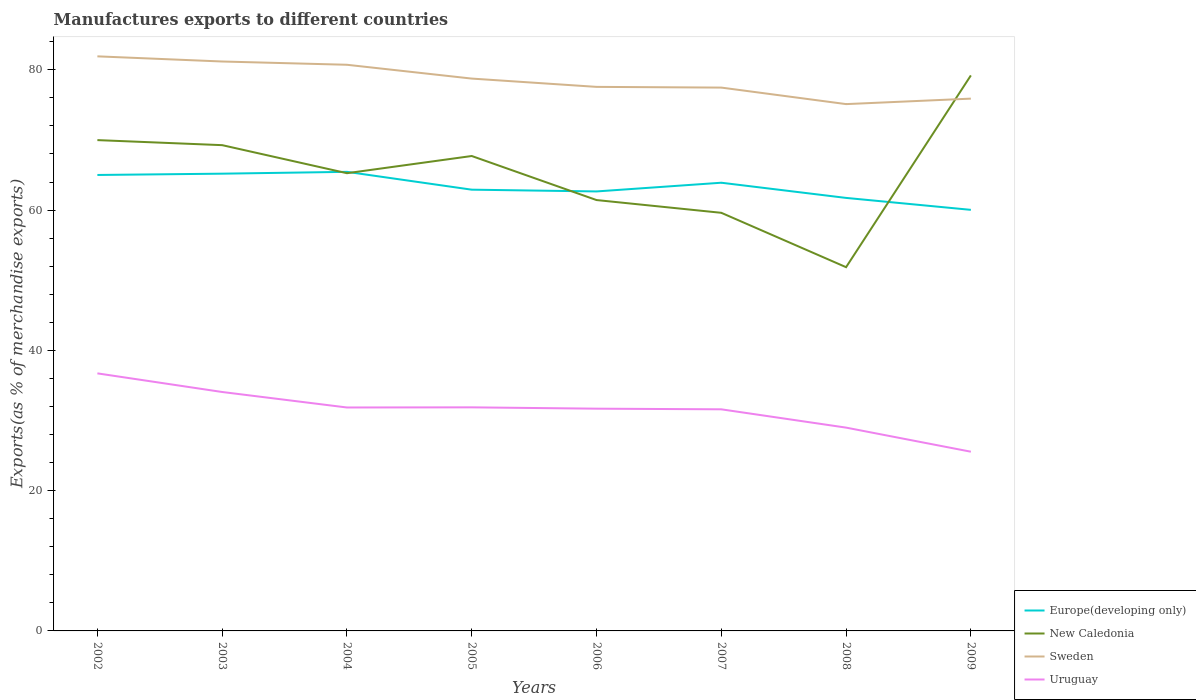Is the number of lines equal to the number of legend labels?
Your answer should be compact. Yes. Across all years, what is the maximum percentage of exports to different countries in New Caledonia?
Your answer should be very brief. 51.86. In which year was the percentage of exports to different countries in New Caledonia maximum?
Provide a succinct answer. 2008. What is the total percentage of exports to different countries in New Caledonia in the graph?
Offer a terse response. 5.65. What is the difference between the highest and the second highest percentage of exports to different countries in Uruguay?
Make the answer very short. 11.17. How many lines are there?
Your response must be concise. 4. How many years are there in the graph?
Provide a short and direct response. 8. Are the values on the major ticks of Y-axis written in scientific E-notation?
Give a very brief answer. No. Does the graph contain grids?
Keep it short and to the point. No. Where does the legend appear in the graph?
Provide a succinct answer. Bottom right. How many legend labels are there?
Your response must be concise. 4. How are the legend labels stacked?
Ensure brevity in your answer.  Vertical. What is the title of the graph?
Offer a terse response. Manufactures exports to different countries. Does "Cyprus" appear as one of the legend labels in the graph?
Offer a terse response. No. What is the label or title of the X-axis?
Give a very brief answer. Years. What is the label or title of the Y-axis?
Keep it short and to the point. Exports(as % of merchandise exports). What is the Exports(as % of merchandise exports) in Europe(developing only) in 2002?
Ensure brevity in your answer.  65.01. What is the Exports(as % of merchandise exports) in New Caledonia in 2002?
Offer a terse response. 69.98. What is the Exports(as % of merchandise exports) in Sweden in 2002?
Your answer should be very brief. 81.92. What is the Exports(as % of merchandise exports) of Uruguay in 2002?
Your answer should be compact. 36.72. What is the Exports(as % of merchandise exports) in Europe(developing only) in 2003?
Your answer should be very brief. 65.2. What is the Exports(as % of merchandise exports) in New Caledonia in 2003?
Your response must be concise. 69.26. What is the Exports(as % of merchandise exports) of Sweden in 2003?
Offer a terse response. 81.19. What is the Exports(as % of merchandise exports) of Uruguay in 2003?
Make the answer very short. 34.07. What is the Exports(as % of merchandise exports) of Europe(developing only) in 2004?
Keep it short and to the point. 65.46. What is the Exports(as % of merchandise exports) in New Caledonia in 2004?
Make the answer very short. 65.26. What is the Exports(as % of merchandise exports) in Sweden in 2004?
Your answer should be compact. 80.72. What is the Exports(as % of merchandise exports) in Uruguay in 2004?
Your answer should be very brief. 31.86. What is the Exports(as % of merchandise exports) of Europe(developing only) in 2005?
Ensure brevity in your answer.  62.91. What is the Exports(as % of merchandise exports) of New Caledonia in 2005?
Offer a very short reply. 67.71. What is the Exports(as % of merchandise exports) of Sweden in 2005?
Keep it short and to the point. 78.75. What is the Exports(as % of merchandise exports) of Uruguay in 2005?
Provide a succinct answer. 31.88. What is the Exports(as % of merchandise exports) of Europe(developing only) in 2006?
Your response must be concise. 62.66. What is the Exports(as % of merchandise exports) in New Caledonia in 2006?
Your answer should be compact. 61.43. What is the Exports(as % of merchandise exports) of Sweden in 2006?
Your response must be concise. 77.57. What is the Exports(as % of merchandise exports) in Uruguay in 2006?
Offer a terse response. 31.69. What is the Exports(as % of merchandise exports) in Europe(developing only) in 2007?
Your answer should be compact. 63.9. What is the Exports(as % of merchandise exports) in New Caledonia in 2007?
Your response must be concise. 59.61. What is the Exports(as % of merchandise exports) of Sweden in 2007?
Your response must be concise. 77.47. What is the Exports(as % of merchandise exports) of Uruguay in 2007?
Make the answer very short. 31.6. What is the Exports(as % of merchandise exports) in Europe(developing only) in 2008?
Give a very brief answer. 61.74. What is the Exports(as % of merchandise exports) in New Caledonia in 2008?
Ensure brevity in your answer.  51.86. What is the Exports(as % of merchandise exports) of Sweden in 2008?
Offer a very short reply. 75.11. What is the Exports(as % of merchandise exports) in Uruguay in 2008?
Keep it short and to the point. 28.99. What is the Exports(as % of merchandise exports) in Europe(developing only) in 2009?
Make the answer very short. 60.04. What is the Exports(as % of merchandise exports) of New Caledonia in 2009?
Give a very brief answer. 79.2. What is the Exports(as % of merchandise exports) of Sweden in 2009?
Offer a very short reply. 75.89. What is the Exports(as % of merchandise exports) in Uruguay in 2009?
Give a very brief answer. 25.55. Across all years, what is the maximum Exports(as % of merchandise exports) in Europe(developing only)?
Keep it short and to the point. 65.46. Across all years, what is the maximum Exports(as % of merchandise exports) of New Caledonia?
Keep it short and to the point. 79.2. Across all years, what is the maximum Exports(as % of merchandise exports) of Sweden?
Ensure brevity in your answer.  81.92. Across all years, what is the maximum Exports(as % of merchandise exports) in Uruguay?
Your answer should be compact. 36.72. Across all years, what is the minimum Exports(as % of merchandise exports) in Europe(developing only)?
Give a very brief answer. 60.04. Across all years, what is the minimum Exports(as % of merchandise exports) of New Caledonia?
Your answer should be very brief. 51.86. Across all years, what is the minimum Exports(as % of merchandise exports) of Sweden?
Ensure brevity in your answer.  75.11. Across all years, what is the minimum Exports(as % of merchandise exports) in Uruguay?
Offer a very short reply. 25.55. What is the total Exports(as % of merchandise exports) of Europe(developing only) in the graph?
Offer a terse response. 506.91. What is the total Exports(as % of merchandise exports) in New Caledonia in the graph?
Provide a succinct answer. 524.33. What is the total Exports(as % of merchandise exports) of Sweden in the graph?
Your response must be concise. 628.63. What is the total Exports(as % of merchandise exports) in Uruguay in the graph?
Your response must be concise. 252.35. What is the difference between the Exports(as % of merchandise exports) in Europe(developing only) in 2002 and that in 2003?
Offer a terse response. -0.19. What is the difference between the Exports(as % of merchandise exports) in New Caledonia in 2002 and that in 2003?
Ensure brevity in your answer.  0.72. What is the difference between the Exports(as % of merchandise exports) of Sweden in 2002 and that in 2003?
Your answer should be compact. 0.74. What is the difference between the Exports(as % of merchandise exports) of Uruguay in 2002 and that in 2003?
Your response must be concise. 2.66. What is the difference between the Exports(as % of merchandise exports) of Europe(developing only) in 2002 and that in 2004?
Provide a succinct answer. -0.45. What is the difference between the Exports(as % of merchandise exports) in New Caledonia in 2002 and that in 2004?
Offer a very short reply. 4.72. What is the difference between the Exports(as % of merchandise exports) in Sweden in 2002 and that in 2004?
Your answer should be very brief. 1.2. What is the difference between the Exports(as % of merchandise exports) in Uruguay in 2002 and that in 2004?
Provide a short and direct response. 4.86. What is the difference between the Exports(as % of merchandise exports) of Europe(developing only) in 2002 and that in 2005?
Your answer should be compact. 2.1. What is the difference between the Exports(as % of merchandise exports) of New Caledonia in 2002 and that in 2005?
Make the answer very short. 2.27. What is the difference between the Exports(as % of merchandise exports) of Sweden in 2002 and that in 2005?
Your answer should be compact. 3.17. What is the difference between the Exports(as % of merchandise exports) in Uruguay in 2002 and that in 2005?
Keep it short and to the point. 4.84. What is the difference between the Exports(as % of merchandise exports) in Europe(developing only) in 2002 and that in 2006?
Your answer should be very brief. 2.35. What is the difference between the Exports(as % of merchandise exports) in New Caledonia in 2002 and that in 2006?
Your response must be concise. 8.55. What is the difference between the Exports(as % of merchandise exports) of Sweden in 2002 and that in 2006?
Ensure brevity in your answer.  4.35. What is the difference between the Exports(as % of merchandise exports) in Uruguay in 2002 and that in 2006?
Give a very brief answer. 5.03. What is the difference between the Exports(as % of merchandise exports) in Europe(developing only) in 2002 and that in 2007?
Make the answer very short. 1.11. What is the difference between the Exports(as % of merchandise exports) in New Caledonia in 2002 and that in 2007?
Your answer should be very brief. 10.37. What is the difference between the Exports(as % of merchandise exports) in Sweden in 2002 and that in 2007?
Ensure brevity in your answer.  4.46. What is the difference between the Exports(as % of merchandise exports) of Uruguay in 2002 and that in 2007?
Provide a succinct answer. 5.13. What is the difference between the Exports(as % of merchandise exports) in Europe(developing only) in 2002 and that in 2008?
Provide a short and direct response. 3.27. What is the difference between the Exports(as % of merchandise exports) in New Caledonia in 2002 and that in 2008?
Your answer should be compact. 18.12. What is the difference between the Exports(as % of merchandise exports) of Sweden in 2002 and that in 2008?
Your response must be concise. 6.81. What is the difference between the Exports(as % of merchandise exports) of Uruguay in 2002 and that in 2008?
Provide a succinct answer. 7.73. What is the difference between the Exports(as % of merchandise exports) in Europe(developing only) in 2002 and that in 2009?
Provide a succinct answer. 4.97. What is the difference between the Exports(as % of merchandise exports) of New Caledonia in 2002 and that in 2009?
Give a very brief answer. -9.22. What is the difference between the Exports(as % of merchandise exports) of Sweden in 2002 and that in 2009?
Keep it short and to the point. 6.03. What is the difference between the Exports(as % of merchandise exports) of Uruguay in 2002 and that in 2009?
Your response must be concise. 11.17. What is the difference between the Exports(as % of merchandise exports) in Europe(developing only) in 2003 and that in 2004?
Offer a very short reply. -0.26. What is the difference between the Exports(as % of merchandise exports) of New Caledonia in 2003 and that in 2004?
Ensure brevity in your answer.  4. What is the difference between the Exports(as % of merchandise exports) in Sweden in 2003 and that in 2004?
Give a very brief answer. 0.47. What is the difference between the Exports(as % of merchandise exports) of Uruguay in 2003 and that in 2004?
Provide a short and direct response. 2.21. What is the difference between the Exports(as % of merchandise exports) in Europe(developing only) in 2003 and that in 2005?
Provide a short and direct response. 2.28. What is the difference between the Exports(as % of merchandise exports) in New Caledonia in 2003 and that in 2005?
Keep it short and to the point. 1.55. What is the difference between the Exports(as % of merchandise exports) of Sweden in 2003 and that in 2005?
Ensure brevity in your answer.  2.44. What is the difference between the Exports(as % of merchandise exports) in Uruguay in 2003 and that in 2005?
Make the answer very short. 2.19. What is the difference between the Exports(as % of merchandise exports) in Europe(developing only) in 2003 and that in 2006?
Your answer should be compact. 2.53. What is the difference between the Exports(as % of merchandise exports) of New Caledonia in 2003 and that in 2006?
Make the answer very short. 7.83. What is the difference between the Exports(as % of merchandise exports) in Sweden in 2003 and that in 2006?
Provide a succinct answer. 3.62. What is the difference between the Exports(as % of merchandise exports) of Uruguay in 2003 and that in 2006?
Your response must be concise. 2.38. What is the difference between the Exports(as % of merchandise exports) in Europe(developing only) in 2003 and that in 2007?
Keep it short and to the point. 1.29. What is the difference between the Exports(as % of merchandise exports) in New Caledonia in 2003 and that in 2007?
Offer a terse response. 9.65. What is the difference between the Exports(as % of merchandise exports) in Sweden in 2003 and that in 2007?
Make the answer very short. 3.72. What is the difference between the Exports(as % of merchandise exports) of Uruguay in 2003 and that in 2007?
Give a very brief answer. 2.47. What is the difference between the Exports(as % of merchandise exports) of Europe(developing only) in 2003 and that in 2008?
Provide a short and direct response. 3.46. What is the difference between the Exports(as % of merchandise exports) in New Caledonia in 2003 and that in 2008?
Your answer should be very brief. 17.4. What is the difference between the Exports(as % of merchandise exports) in Sweden in 2003 and that in 2008?
Your answer should be very brief. 6.07. What is the difference between the Exports(as % of merchandise exports) in Uruguay in 2003 and that in 2008?
Give a very brief answer. 5.08. What is the difference between the Exports(as % of merchandise exports) of Europe(developing only) in 2003 and that in 2009?
Provide a succinct answer. 5.16. What is the difference between the Exports(as % of merchandise exports) in New Caledonia in 2003 and that in 2009?
Give a very brief answer. -9.94. What is the difference between the Exports(as % of merchandise exports) in Sweden in 2003 and that in 2009?
Your answer should be compact. 5.29. What is the difference between the Exports(as % of merchandise exports) in Uruguay in 2003 and that in 2009?
Ensure brevity in your answer.  8.52. What is the difference between the Exports(as % of merchandise exports) of Europe(developing only) in 2004 and that in 2005?
Offer a very short reply. 2.54. What is the difference between the Exports(as % of merchandise exports) of New Caledonia in 2004 and that in 2005?
Provide a short and direct response. -2.45. What is the difference between the Exports(as % of merchandise exports) in Sweden in 2004 and that in 2005?
Provide a short and direct response. 1.97. What is the difference between the Exports(as % of merchandise exports) in Uruguay in 2004 and that in 2005?
Your response must be concise. -0.02. What is the difference between the Exports(as % of merchandise exports) in Europe(developing only) in 2004 and that in 2006?
Provide a short and direct response. 2.79. What is the difference between the Exports(as % of merchandise exports) of New Caledonia in 2004 and that in 2006?
Provide a short and direct response. 3.83. What is the difference between the Exports(as % of merchandise exports) in Sweden in 2004 and that in 2006?
Make the answer very short. 3.15. What is the difference between the Exports(as % of merchandise exports) of Uruguay in 2004 and that in 2006?
Provide a short and direct response. 0.17. What is the difference between the Exports(as % of merchandise exports) of Europe(developing only) in 2004 and that in 2007?
Ensure brevity in your answer.  1.55. What is the difference between the Exports(as % of merchandise exports) in New Caledonia in 2004 and that in 2007?
Give a very brief answer. 5.65. What is the difference between the Exports(as % of merchandise exports) in Sweden in 2004 and that in 2007?
Your response must be concise. 3.25. What is the difference between the Exports(as % of merchandise exports) in Uruguay in 2004 and that in 2007?
Ensure brevity in your answer.  0.26. What is the difference between the Exports(as % of merchandise exports) in Europe(developing only) in 2004 and that in 2008?
Give a very brief answer. 3.72. What is the difference between the Exports(as % of merchandise exports) in New Caledonia in 2004 and that in 2008?
Provide a short and direct response. 13.4. What is the difference between the Exports(as % of merchandise exports) of Sweden in 2004 and that in 2008?
Your answer should be very brief. 5.61. What is the difference between the Exports(as % of merchandise exports) of Uruguay in 2004 and that in 2008?
Ensure brevity in your answer.  2.87. What is the difference between the Exports(as % of merchandise exports) in Europe(developing only) in 2004 and that in 2009?
Make the answer very short. 5.42. What is the difference between the Exports(as % of merchandise exports) of New Caledonia in 2004 and that in 2009?
Give a very brief answer. -13.94. What is the difference between the Exports(as % of merchandise exports) of Sweden in 2004 and that in 2009?
Offer a terse response. 4.83. What is the difference between the Exports(as % of merchandise exports) in Uruguay in 2004 and that in 2009?
Your answer should be compact. 6.31. What is the difference between the Exports(as % of merchandise exports) of Europe(developing only) in 2005 and that in 2006?
Provide a succinct answer. 0.25. What is the difference between the Exports(as % of merchandise exports) in New Caledonia in 2005 and that in 2006?
Provide a short and direct response. 6.28. What is the difference between the Exports(as % of merchandise exports) in Sweden in 2005 and that in 2006?
Keep it short and to the point. 1.18. What is the difference between the Exports(as % of merchandise exports) in Uruguay in 2005 and that in 2006?
Give a very brief answer. 0.19. What is the difference between the Exports(as % of merchandise exports) of Europe(developing only) in 2005 and that in 2007?
Offer a terse response. -0.99. What is the difference between the Exports(as % of merchandise exports) in New Caledonia in 2005 and that in 2007?
Your answer should be very brief. 8.1. What is the difference between the Exports(as % of merchandise exports) of Sweden in 2005 and that in 2007?
Give a very brief answer. 1.28. What is the difference between the Exports(as % of merchandise exports) of Uruguay in 2005 and that in 2007?
Your response must be concise. 0.28. What is the difference between the Exports(as % of merchandise exports) of Europe(developing only) in 2005 and that in 2008?
Provide a succinct answer. 1.17. What is the difference between the Exports(as % of merchandise exports) of New Caledonia in 2005 and that in 2008?
Your answer should be compact. 15.85. What is the difference between the Exports(as % of merchandise exports) in Sweden in 2005 and that in 2008?
Ensure brevity in your answer.  3.64. What is the difference between the Exports(as % of merchandise exports) of Uruguay in 2005 and that in 2008?
Your response must be concise. 2.89. What is the difference between the Exports(as % of merchandise exports) in Europe(developing only) in 2005 and that in 2009?
Give a very brief answer. 2.88. What is the difference between the Exports(as % of merchandise exports) of New Caledonia in 2005 and that in 2009?
Keep it short and to the point. -11.49. What is the difference between the Exports(as % of merchandise exports) in Sweden in 2005 and that in 2009?
Your answer should be very brief. 2.86. What is the difference between the Exports(as % of merchandise exports) in Uruguay in 2005 and that in 2009?
Provide a succinct answer. 6.33. What is the difference between the Exports(as % of merchandise exports) in Europe(developing only) in 2006 and that in 2007?
Keep it short and to the point. -1.24. What is the difference between the Exports(as % of merchandise exports) of New Caledonia in 2006 and that in 2007?
Offer a terse response. 1.82. What is the difference between the Exports(as % of merchandise exports) in Sweden in 2006 and that in 2007?
Your answer should be compact. 0.1. What is the difference between the Exports(as % of merchandise exports) of Uruguay in 2006 and that in 2007?
Your answer should be very brief. 0.09. What is the difference between the Exports(as % of merchandise exports) in Europe(developing only) in 2006 and that in 2008?
Ensure brevity in your answer.  0.92. What is the difference between the Exports(as % of merchandise exports) of New Caledonia in 2006 and that in 2008?
Your answer should be compact. 9.57. What is the difference between the Exports(as % of merchandise exports) in Sweden in 2006 and that in 2008?
Your answer should be very brief. 2.46. What is the difference between the Exports(as % of merchandise exports) in Uruguay in 2006 and that in 2008?
Your answer should be very brief. 2.7. What is the difference between the Exports(as % of merchandise exports) of Europe(developing only) in 2006 and that in 2009?
Give a very brief answer. 2.63. What is the difference between the Exports(as % of merchandise exports) of New Caledonia in 2006 and that in 2009?
Offer a terse response. -17.77. What is the difference between the Exports(as % of merchandise exports) of Sweden in 2006 and that in 2009?
Your answer should be compact. 1.68. What is the difference between the Exports(as % of merchandise exports) in Uruguay in 2006 and that in 2009?
Offer a terse response. 6.14. What is the difference between the Exports(as % of merchandise exports) in Europe(developing only) in 2007 and that in 2008?
Give a very brief answer. 2.16. What is the difference between the Exports(as % of merchandise exports) of New Caledonia in 2007 and that in 2008?
Provide a short and direct response. 7.75. What is the difference between the Exports(as % of merchandise exports) in Sweden in 2007 and that in 2008?
Keep it short and to the point. 2.35. What is the difference between the Exports(as % of merchandise exports) of Uruguay in 2007 and that in 2008?
Ensure brevity in your answer.  2.61. What is the difference between the Exports(as % of merchandise exports) in Europe(developing only) in 2007 and that in 2009?
Your answer should be very brief. 3.87. What is the difference between the Exports(as % of merchandise exports) of New Caledonia in 2007 and that in 2009?
Give a very brief answer. -19.59. What is the difference between the Exports(as % of merchandise exports) of Sweden in 2007 and that in 2009?
Give a very brief answer. 1.57. What is the difference between the Exports(as % of merchandise exports) in Uruguay in 2007 and that in 2009?
Give a very brief answer. 6.04. What is the difference between the Exports(as % of merchandise exports) in Europe(developing only) in 2008 and that in 2009?
Provide a short and direct response. 1.7. What is the difference between the Exports(as % of merchandise exports) of New Caledonia in 2008 and that in 2009?
Provide a succinct answer. -27.34. What is the difference between the Exports(as % of merchandise exports) in Sweden in 2008 and that in 2009?
Provide a succinct answer. -0.78. What is the difference between the Exports(as % of merchandise exports) in Uruguay in 2008 and that in 2009?
Make the answer very short. 3.44. What is the difference between the Exports(as % of merchandise exports) of Europe(developing only) in 2002 and the Exports(as % of merchandise exports) of New Caledonia in 2003?
Give a very brief answer. -4.25. What is the difference between the Exports(as % of merchandise exports) of Europe(developing only) in 2002 and the Exports(as % of merchandise exports) of Sweden in 2003?
Give a very brief answer. -16.18. What is the difference between the Exports(as % of merchandise exports) in Europe(developing only) in 2002 and the Exports(as % of merchandise exports) in Uruguay in 2003?
Provide a short and direct response. 30.94. What is the difference between the Exports(as % of merchandise exports) of New Caledonia in 2002 and the Exports(as % of merchandise exports) of Sweden in 2003?
Provide a short and direct response. -11.21. What is the difference between the Exports(as % of merchandise exports) of New Caledonia in 2002 and the Exports(as % of merchandise exports) of Uruguay in 2003?
Provide a short and direct response. 35.91. What is the difference between the Exports(as % of merchandise exports) in Sweden in 2002 and the Exports(as % of merchandise exports) in Uruguay in 2003?
Offer a terse response. 47.86. What is the difference between the Exports(as % of merchandise exports) in Europe(developing only) in 2002 and the Exports(as % of merchandise exports) in New Caledonia in 2004?
Your response must be concise. -0.25. What is the difference between the Exports(as % of merchandise exports) of Europe(developing only) in 2002 and the Exports(as % of merchandise exports) of Sweden in 2004?
Offer a terse response. -15.71. What is the difference between the Exports(as % of merchandise exports) in Europe(developing only) in 2002 and the Exports(as % of merchandise exports) in Uruguay in 2004?
Make the answer very short. 33.15. What is the difference between the Exports(as % of merchandise exports) of New Caledonia in 2002 and the Exports(as % of merchandise exports) of Sweden in 2004?
Offer a very short reply. -10.74. What is the difference between the Exports(as % of merchandise exports) of New Caledonia in 2002 and the Exports(as % of merchandise exports) of Uruguay in 2004?
Your answer should be very brief. 38.12. What is the difference between the Exports(as % of merchandise exports) of Sweden in 2002 and the Exports(as % of merchandise exports) of Uruguay in 2004?
Your response must be concise. 50.07. What is the difference between the Exports(as % of merchandise exports) in Europe(developing only) in 2002 and the Exports(as % of merchandise exports) in New Caledonia in 2005?
Offer a very short reply. -2.7. What is the difference between the Exports(as % of merchandise exports) in Europe(developing only) in 2002 and the Exports(as % of merchandise exports) in Sweden in 2005?
Make the answer very short. -13.74. What is the difference between the Exports(as % of merchandise exports) of Europe(developing only) in 2002 and the Exports(as % of merchandise exports) of Uruguay in 2005?
Your answer should be compact. 33.13. What is the difference between the Exports(as % of merchandise exports) of New Caledonia in 2002 and the Exports(as % of merchandise exports) of Sweden in 2005?
Give a very brief answer. -8.77. What is the difference between the Exports(as % of merchandise exports) of New Caledonia in 2002 and the Exports(as % of merchandise exports) of Uruguay in 2005?
Keep it short and to the point. 38.1. What is the difference between the Exports(as % of merchandise exports) in Sweden in 2002 and the Exports(as % of merchandise exports) in Uruguay in 2005?
Provide a succinct answer. 50.05. What is the difference between the Exports(as % of merchandise exports) of Europe(developing only) in 2002 and the Exports(as % of merchandise exports) of New Caledonia in 2006?
Provide a short and direct response. 3.58. What is the difference between the Exports(as % of merchandise exports) in Europe(developing only) in 2002 and the Exports(as % of merchandise exports) in Sweden in 2006?
Your response must be concise. -12.56. What is the difference between the Exports(as % of merchandise exports) of Europe(developing only) in 2002 and the Exports(as % of merchandise exports) of Uruguay in 2006?
Make the answer very short. 33.32. What is the difference between the Exports(as % of merchandise exports) of New Caledonia in 2002 and the Exports(as % of merchandise exports) of Sweden in 2006?
Ensure brevity in your answer.  -7.59. What is the difference between the Exports(as % of merchandise exports) of New Caledonia in 2002 and the Exports(as % of merchandise exports) of Uruguay in 2006?
Your answer should be compact. 38.29. What is the difference between the Exports(as % of merchandise exports) in Sweden in 2002 and the Exports(as % of merchandise exports) in Uruguay in 2006?
Ensure brevity in your answer.  50.23. What is the difference between the Exports(as % of merchandise exports) in Europe(developing only) in 2002 and the Exports(as % of merchandise exports) in New Caledonia in 2007?
Provide a short and direct response. 5.4. What is the difference between the Exports(as % of merchandise exports) of Europe(developing only) in 2002 and the Exports(as % of merchandise exports) of Sweden in 2007?
Ensure brevity in your answer.  -12.46. What is the difference between the Exports(as % of merchandise exports) of Europe(developing only) in 2002 and the Exports(as % of merchandise exports) of Uruguay in 2007?
Provide a short and direct response. 33.41. What is the difference between the Exports(as % of merchandise exports) in New Caledonia in 2002 and the Exports(as % of merchandise exports) in Sweden in 2007?
Give a very brief answer. -7.49. What is the difference between the Exports(as % of merchandise exports) in New Caledonia in 2002 and the Exports(as % of merchandise exports) in Uruguay in 2007?
Offer a terse response. 38.38. What is the difference between the Exports(as % of merchandise exports) of Sweden in 2002 and the Exports(as % of merchandise exports) of Uruguay in 2007?
Provide a short and direct response. 50.33. What is the difference between the Exports(as % of merchandise exports) in Europe(developing only) in 2002 and the Exports(as % of merchandise exports) in New Caledonia in 2008?
Your response must be concise. 13.15. What is the difference between the Exports(as % of merchandise exports) of Europe(developing only) in 2002 and the Exports(as % of merchandise exports) of Sweden in 2008?
Keep it short and to the point. -10.1. What is the difference between the Exports(as % of merchandise exports) in Europe(developing only) in 2002 and the Exports(as % of merchandise exports) in Uruguay in 2008?
Your answer should be compact. 36.02. What is the difference between the Exports(as % of merchandise exports) in New Caledonia in 2002 and the Exports(as % of merchandise exports) in Sweden in 2008?
Your answer should be very brief. -5.13. What is the difference between the Exports(as % of merchandise exports) of New Caledonia in 2002 and the Exports(as % of merchandise exports) of Uruguay in 2008?
Offer a very short reply. 40.99. What is the difference between the Exports(as % of merchandise exports) of Sweden in 2002 and the Exports(as % of merchandise exports) of Uruguay in 2008?
Your answer should be compact. 52.94. What is the difference between the Exports(as % of merchandise exports) in Europe(developing only) in 2002 and the Exports(as % of merchandise exports) in New Caledonia in 2009?
Your answer should be very brief. -14.19. What is the difference between the Exports(as % of merchandise exports) in Europe(developing only) in 2002 and the Exports(as % of merchandise exports) in Sweden in 2009?
Offer a terse response. -10.88. What is the difference between the Exports(as % of merchandise exports) in Europe(developing only) in 2002 and the Exports(as % of merchandise exports) in Uruguay in 2009?
Your answer should be very brief. 39.46. What is the difference between the Exports(as % of merchandise exports) in New Caledonia in 2002 and the Exports(as % of merchandise exports) in Sweden in 2009?
Your answer should be very brief. -5.91. What is the difference between the Exports(as % of merchandise exports) in New Caledonia in 2002 and the Exports(as % of merchandise exports) in Uruguay in 2009?
Ensure brevity in your answer.  44.43. What is the difference between the Exports(as % of merchandise exports) of Sweden in 2002 and the Exports(as % of merchandise exports) of Uruguay in 2009?
Offer a terse response. 56.37. What is the difference between the Exports(as % of merchandise exports) in Europe(developing only) in 2003 and the Exports(as % of merchandise exports) in New Caledonia in 2004?
Provide a succinct answer. -0.07. What is the difference between the Exports(as % of merchandise exports) of Europe(developing only) in 2003 and the Exports(as % of merchandise exports) of Sweden in 2004?
Give a very brief answer. -15.53. What is the difference between the Exports(as % of merchandise exports) in Europe(developing only) in 2003 and the Exports(as % of merchandise exports) in Uruguay in 2004?
Offer a very short reply. 33.34. What is the difference between the Exports(as % of merchandise exports) in New Caledonia in 2003 and the Exports(as % of merchandise exports) in Sweden in 2004?
Offer a terse response. -11.46. What is the difference between the Exports(as % of merchandise exports) of New Caledonia in 2003 and the Exports(as % of merchandise exports) of Uruguay in 2004?
Offer a terse response. 37.4. What is the difference between the Exports(as % of merchandise exports) of Sweden in 2003 and the Exports(as % of merchandise exports) of Uruguay in 2004?
Your answer should be very brief. 49.33. What is the difference between the Exports(as % of merchandise exports) in Europe(developing only) in 2003 and the Exports(as % of merchandise exports) in New Caledonia in 2005?
Offer a very short reply. -2.52. What is the difference between the Exports(as % of merchandise exports) of Europe(developing only) in 2003 and the Exports(as % of merchandise exports) of Sweden in 2005?
Ensure brevity in your answer.  -13.56. What is the difference between the Exports(as % of merchandise exports) of Europe(developing only) in 2003 and the Exports(as % of merchandise exports) of Uruguay in 2005?
Keep it short and to the point. 33.32. What is the difference between the Exports(as % of merchandise exports) of New Caledonia in 2003 and the Exports(as % of merchandise exports) of Sweden in 2005?
Ensure brevity in your answer.  -9.49. What is the difference between the Exports(as % of merchandise exports) in New Caledonia in 2003 and the Exports(as % of merchandise exports) in Uruguay in 2005?
Keep it short and to the point. 37.38. What is the difference between the Exports(as % of merchandise exports) of Sweden in 2003 and the Exports(as % of merchandise exports) of Uruguay in 2005?
Keep it short and to the point. 49.31. What is the difference between the Exports(as % of merchandise exports) in Europe(developing only) in 2003 and the Exports(as % of merchandise exports) in New Caledonia in 2006?
Offer a terse response. 3.76. What is the difference between the Exports(as % of merchandise exports) in Europe(developing only) in 2003 and the Exports(as % of merchandise exports) in Sweden in 2006?
Keep it short and to the point. -12.37. What is the difference between the Exports(as % of merchandise exports) of Europe(developing only) in 2003 and the Exports(as % of merchandise exports) of Uruguay in 2006?
Provide a short and direct response. 33.51. What is the difference between the Exports(as % of merchandise exports) in New Caledonia in 2003 and the Exports(as % of merchandise exports) in Sweden in 2006?
Your answer should be compact. -8.31. What is the difference between the Exports(as % of merchandise exports) in New Caledonia in 2003 and the Exports(as % of merchandise exports) in Uruguay in 2006?
Offer a terse response. 37.57. What is the difference between the Exports(as % of merchandise exports) in Sweden in 2003 and the Exports(as % of merchandise exports) in Uruguay in 2006?
Provide a short and direct response. 49.5. What is the difference between the Exports(as % of merchandise exports) in Europe(developing only) in 2003 and the Exports(as % of merchandise exports) in New Caledonia in 2007?
Give a very brief answer. 5.58. What is the difference between the Exports(as % of merchandise exports) of Europe(developing only) in 2003 and the Exports(as % of merchandise exports) of Sweden in 2007?
Keep it short and to the point. -12.27. What is the difference between the Exports(as % of merchandise exports) in Europe(developing only) in 2003 and the Exports(as % of merchandise exports) in Uruguay in 2007?
Your answer should be very brief. 33.6. What is the difference between the Exports(as % of merchandise exports) in New Caledonia in 2003 and the Exports(as % of merchandise exports) in Sweden in 2007?
Provide a succinct answer. -8.21. What is the difference between the Exports(as % of merchandise exports) of New Caledonia in 2003 and the Exports(as % of merchandise exports) of Uruguay in 2007?
Make the answer very short. 37.66. What is the difference between the Exports(as % of merchandise exports) of Sweden in 2003 and the Exports(as % of merchandise exports) of Uruguay in 2007?
Make the answer very short. 49.59. What is the difference between the Exports(as % of merchandise exports) of Europe(developing only) in 2003 and the Exports(as % of merchandise exports) of New Caledonia in 2008?
Your response must be concise. 13.33. What is the difference between the Exports(as % of merchandise exports) in Europe(developing only) in 2003 and the Exports(as % of merchandise exports) in Sweden in 2008?
Make the answer very short. -9.92. What is the difference between the Exports(as % of merchandise exports) in Europe(developing only) in 2003 and the Exports(as % of merchandise exports) in Uruguay in 2008?
Your answer should be very brief. 36.21. What is the difference between the Exports(as % of merchandise exports) of New Caledonia in 2003 and the Exports(as % of merchandise exports) of Sweden in 2008?
Make the answer very short. -5.85. What is the difference between the Exports(as % of merchandise exports) of New Caledonia in 2003 and the Exports(as % of merchandise exports) of Uruguay in 2008?
Keep it short and to the point. 40.27. What is the difference between the Exports(as % of merchandise exports) of Sweden in 2003 and the Exports(as % of merchandise exports) of Uruguay in 2008?
Your answer should be compact. 52.2. What is the difference between the Exports(as % of merchandise exports) in Europe(developing only) in 2003 and the Exports(as % of merchandise exports) in New Caledonia in 2009?
Provide a succinct answer. -14.01. What is the difference between the Exports(as % of merchandise exports) of Europe(developing only) in 2003 and the Exports(as % of merchandise exports) of Sweden in 2009?
Provide a succinct answer. -10.7. What is the difference between the Exports(as % of merchandise exports) of Europe(developing only) in 2003 and the Exports(as % of merchandise exports) of Uruguay in 2009?
Make the answer very short. 39.64. What is the difference between the Exports(as % of merchandise exports) in New Caledonia in 2003 and the Exports(as % of merchandise exports) in Sweden in 2009?
Ensure brevity in your answer.  -6.63. What is the difference between the Exports(as % of merchandise exports) in New Caledonia in 2003 and the Exports(as % of merchandise exports) in Uruguay in 2009?
Keep it short and to the point. 43.71. What is the difference between the Exports(as % of merchandise exports) of Sweden in 2003 and the Exports(as % of merchandise exports) of Uruguay in 2009?
Offer a terse response. 55.64. What is the difference between the Exports(as % of merchandise exports) in Europe(developing only) in 2004 and the Exports(as % of merchandise exports) in New Caledonia in 2005?
Your answer should be very brief. -2.26. What is the difference between the Exports(as % of merchandise exports) of Europe(developing only) in 2004 and the Exports(as % of merchandise exports) of Sweden in 2005?
Provide a succinct answer. -13.3. What is the difference between the Exports(as % of merchandise exports) in Europe(developing only) in 2004 and the Exports(as % of merchandise exports) in Uruguay in 2005?
Keep it short and to the point. 33.58. What is the difference between the Exports(as % of merchandise exports) of New Caledonia in 2004 and the Exports(as % of merchandise exports) of Sweden in 2005?
Provide a succinct answer. -13.49. What is the difference between the Exports(as % of merchandise exports) in New Caledonia in 2004 and the Exports(as % of merchandise exports) in Uruguay in 2005?
Your answer should be very brief. 33.38. What is the difference between the Exports(as % of merchandise exports) of Sweden in 2004 and the Exports(as % of merchandise exports) of Uruguay in 2005?
Your response must be concise. 48.84. What is the difference between the Exports(as % of merchandise exports) in Europe(developing only) in 2004 and the Exports(as % of merchandise exports) in New Caledonia in 2006?
Provide a succinct answer. 4.02. What is the difference between the Exports(as % of merchandise exports) in Europe(developing only) in 2004 and the Exports(as % of merchandise exports) in Sweden in 2006?
Your response must be concise. -12.11. What is the difference between the Exports(as % of merchandise exports) of Europe(developing only) in 2004 and the Exports(as % of merchandise exports) of Uruguay in 2006?
Provide a short and direct response. 33.77. What is the difference between the Exports(as % of merchandise exports) of New Caledonia in 2004 and the Exports(as % of merchandise exports) of Sweden in 2006?
Your response must be concise. -12.31. What is the difference between the Exports(as % of merchandise exports) of New Caledonia in 2004 and the Exports(as % of merchandise exports) of Uruguay in 2006?
Ensure brevity in your answer.  33.57. What is the difference between the Exports(as % of merchandise exports) of Sweden in 2004 and the Exports(as % of merchandise exports) of Uruguay in 2006?
Keep it short and to the point. 49.03. What is the difference between the Exports(as % of merchandise exports) of Europe(developing only) in 2004 and the Exports(as % of merchandise exports) of New Caledonia in 2007?
Your answer should be very brief. 5.84. What is the difference between the Exports(as % of merchandise exports) in Europe(developing only) in 2004 and the Exports(as % of merchandise exports) in Sweden in 2007?
Ensure brevity in your answer.  -12.01. What is the difference between the Exports(as % of merchandise exports) in Europe(developing only) in 2004 and the Exports(as % of merchandise exports) in Uruguay in 2007?
Your response must be concise. 33.86. What is the difference between the Exports(as % of merchandise exports) of New Caledonia in 2004 and the Exports(as % of merchandise exports) of Sweden in 2007?
Your answer should be very brief. -12.21. What is the difference between the Exports(as % of merchandise exports) in New Caledonia in 2004 and the Exports(as % of merchandise exports) in Uruguay in 2007?
Offer a terse response. 33.67. What is the difference between the Exports(as % of merchandise exports) of Sweden in 2004 and the Exports(as % of merchandise exports) of Uruguay in 2007?
Give a very brief answer. 49.13. What is the difference between the Exports(as % of merchandise exports) in Europe(developing only) in 2004 and the Exports(as % of merchandise exports) in New Caledonia in 2008?
Keep it short and to the point. 13.59. What is the difference between the Exports(as % of merchandise exports) in Europe(developing only) in 2004 and the Exports(as % of merchandise exports) in Sweden in 2008?
Your answer should be very brief. -9.66. What is the difference between the Exports(as % of merchandise exports) of Europe(developing only) in 2004 and the Exports(as % of merchandise exports) of Uruguay in 2008?
Provide a succinct answer. 36.47. What is the difference between the Exports(as % of merchandise exports) in New Caledonia in 2004 and the Exports(as % of merchandise exports) in Sweden in 2008?
Make the answer very short. -9.85. What is the difference between the Exports(as % of merchandise exports) of New Caledonia in 2004 and the Exports(as % of merchandise exports) of Uruguay in 2008?
Offer a terse response. 36.28. What is the difference between the Exports(as % of merchandise exports) in Sweden in 2004 and the Exports(as % of merchandise exports) in Uruguay in 2008?
Give a very brief answer. 51.73. What is the difference between the Exports(as % of merchandise exports) in Europe(developing only) in 2004 and the Exports(as % of merchandise exports) in New Caledonia in 2009?
Your answer should be very brief. -13.75. What is the difference between the Exports(as % of merchandise exports) in Europe(developing only) in 2004 and the Exports(as % of merchandise exports) in Sweden in 2009?
Your answer should be very brief. -10.44. What is the difference between the Exports(as % of merchandise exports) in Europe(developing only) in 2004 and the Exports(as % of merchandise exports) in Uruguay in 2009?
Ensure brevity in your answer.  39.9. What is the difference between the Exports(as % of merchandise exports) of New Caledonia in 2004 and the Exports(as % of merchandise exports) of Sweden in 2009?
Your answer should be compact. -10.63. What is the difference between the Exports(as % of merchandise exports) in New Caledonia in 2004 and the Exports(as % of merchandise exports) in Uruguay in 2009?
Your answer should be very brief. 39.71. What is the difference between the Exports(as % of merchandise exports) of Sweden in 2004 and the Exports(as % of merchandise exports) of Uruguay in 2009?
Your response must be concise. 55.17. What is the difference between the Exports(as % of merchandise exports) of Europe(developing only) in 2005 and the Exports(as % of merchandise exports) of New Caledonia in 2006?
Give a very brief answer. 1.48. What is the difference between the Exports(as % of merchandise exports) in Europe(developing only) in 2005 and the Exports(as % of merchandise exports) in Sweden in 2006?
Your response must be concise. -14.66. What is the difference between the Exports(as % of merchandise exports) of Europe(developing only) in 2005 and the Exports(as % of merchandise exports) of Uruguay in 2006?
Keep it short and to the point. 31.22. What is the difference between the Exports(as % of merchandise exports) of New Caledonia in 2005 and the Exports(as % of merchandise exports) of Sweden in 2006?
Keep it short and to the point. -9.86. What is the difference between the Exports(as % of merchandise exports) of New Caledonia in 2005 and the Exports(as % of merchandise exports) of Uruguay in 2006?
Offer a terse response. 36.03. What is the difference between the Exports(as % of merchandise exports) in Sweden in 2005 and the Exports(as % of merchandise exports) in Uruguay in 2006?
Your answer should be compact. 47.06. What is the difference between the Exports(as % of merchandise exports) of Europe(developing only) in 2005 and the Exports(as % of merchandise exports) of New Caledonia in 2007?
Give a very brief answer. 3.3. What is the difference between the Exports(as % of merchandise exports) in Europe(developing only) in 2005 and the Exports(as % of merchandise exports) in Sweden in 2007?
Keep it short and to the point. -14.56. What is the difference between the Exports(as % of merchandise exports) in Europe(developing only) in 2005 and the Exports(as % of merchandise exports) in Uruguay in 2007?
Offer a terse response. 31.32. What is the difference between the Exports(as % of merchandise exports) of New Caledonia in 2005 and the Exports(as % of merchandise exports) of Sweden in 2007?
Keep it short and to the point. -9.75. What is the difference between the Exports(as % of merchandise exports) in New Caledonia in 2005 and the Exports(as % of merchandise exports) in Uruguay in 2007?
Give a very brief answer. 36.12. What is the difference between the Exports(as % of merchandise exports) of Sweden in 2005 and the Exports(as % of merchandise exports) of Uruguay in 2007?
Provide a succinct answer. 47.16. What is the difference between the Exports(as % of merchandise exports) of Europe(developing only) in 2005 and the Exports(as % of merchandise exports) of New Caledonia in 2008?
Your answer should be very brief. 11.05. What is the difference between the Exports(as % of merchandise exports) in Europe(developing only) in 2005 and the Exports(as % of merchandise exports) in Sweden in 2008?
Keep it short and to the point. -12.2. What is the difference between the Exports(as % of merchandise exports) of Europe(developing only) in 2005 and the Exports(as % of merchandise exports) of Uruguay in 2008?
Give a very brief answer. 33.93. What is the difference between the Exports(as % of merchandise exports) of New Caledonia in 2005 and the Exports(as % of merchandise exports) of Sweden in 2008?
Offer a very short reply. -7.4. What is the difference between the Exports(as % of merchandise exports) of New Caledonia in 2005 and the Exports(as % of merchandise exports) of Uruguay in 2008?
Give a very brief answer. 38.73. What is the difference between the Exports(as % of merchandise exports) in Sweden in 2005 and the Exports(as % of merchandise exports) in Uruguay in 2008?
Your response must be concise. 49.77. What is the difference between the Exports(as % of merchandise exports) of Europe(developing only) in 2005 and the Exports(as % of merchandise exports) of New Caledonia in 2009?
Your answer should be compact. -16.29. What is the difference between the Exports(as % of merchandise exports) in Europe(developing only) in 2005 and the Exports(as % of merchandise exports) in Sweden in 2009?
Make the answer very short. -12.98. What is the difference between the Exports(as % of merchandise exports) of Europe(developing only) in 2005 and the Exports(as % of merchandise exports) of Uruguay in 2009?
Make the answer very short. 37.36. What is the difference between the Exports(as % of merchandise exports) in New Caledonia in 2005 and the Exports(as % of merchandise exports) in Sweden in 2009?
Keep it short and to the point. -8.18. What is the difference between the Exports(as % of merchandise exports) in New Caledonia in 2005 and the Exports(as % of merchandise exports) in Uruguay in 2009?
Offer a very short reply. 42.16. What is the difference between the Exports(as % of merchandise exports) of Sweden in 2005 and the Exports(as % of merchandise exports) of Uruguay in 2009?
Offer a terse response. 53.2. What is the difference between the Exports(as % of merchandise exports) in Europe(developing only) in 2006 and the Exports(as % of merchandise exports) in New Caledonia in 2007?
Your answer should be very brief. 3.05. What is the difference between the Exports(as % of merchandise exports) in Europe(developing only) in 2006 and the Exports(as % of merchandise exports) in Sweden in 2007?
Ensure brevity in your answer.  -14.81. What is the difference between the Exports(as % of merchandise exports) in Europe(developing only) in 2006 and the Exports(as % of merchandise exports) in Uruguay in 2007?
Your answer should be very brief. 31.07. What is the difference between the Exports(as % of merchandise exports) in New Caledonia in 2006 and the Exports(as % of merchandise exports) in Sweden in 2007?
Ensure brevity in your answer.  -16.03. What is the difference between the Exports(as % of merchandise exports) of New Caledonia in 2006 and the Exports(as % of merchandise exports) of Uruguay in 2007?
Give a very brief answer. 29.84. What is the difference between the Exports(as % of merchandise exports) of Sweden in 2006 and the Exports(as % of merchandise exports) of Uruguay in 2007?
Provide a short and direct response. 45.97. What is the difference between the Exports(as % of merchandise exports) of Europe(developing only) in 2006 and the Exports(as % of merchandise exports) of New Caledonia in 2008?
Your answer should be compact. 10.8. What is the difference between the Exports(as % of merchandise exports) of Europe(developing only) in 2006 and the Exports(as % of merchandise exports) of Sweden in 2008?
Provide a succinct answer. -12.45. What is the difference between the Exports(as % of merchandise exports) of Europe(developing only) in 2006 and the Exports(as % of merchandise exports) of Uruguay in 2008?
Provide a short and direct response. 33.67. What is the difference between the Exports(as % of merchandise exports) of New Caledonia in 2006 and the Exports(as % of merchandise exports) of Sweden in 2008?
Your answer should be very brief. -13.68. What is the difference between the Exports(as % of merchandise exports) in New Caledonia in 2006 and the Exports(as % of merchandise exports) in Uruguay in 2008?
Offer a very short reply. 32.45. What is the difference between the Exports(as % of merchandise exports) in Sweden in 2006 and the Exports(as % of merchandise exports) in Uruguay in 2008?
Offer a very short reply. 48.58. What is the difference between the Exports(as % of merchandise exports) of Europe(developing only) in 2006 and the Exports(as % of merchandise exports) of New Caledonia in 2009?
Make the answer very short. -16.54. What is the difference between the Exports(as % of merchandise exports) of Europe(developing only) in 2006 and the Exports(as % of merchandise exports) of Sweden in 2009?
Your response must be concise. -13.23. What is the difference between the Exports(as % of merchandise exports) of Europe(developing only) in 2006 and the Exports(as % of merchandise exports) of Uruguay in 2009?
Provide a succinct answer. 37.11. What is the difference between the Exports(as % of merchandise exports) in New Caledonia in 2006 and the Exports(as % of merchandise exports) in Sweden in 2009?
Your answer should be compact. -14.46. What is the difference between the Exports(as % of merchandise exports) of New Caledonia in 2006 and the Exports(as % of merchandise exports) of Uruguay in 2009?
Your response must be concise. 35.88. What is the difference between the Exports(as % of merchandise exports) in Sweden in 2006 and the Exports(as % of merchandise exports) in Uruguay in 2009?
Offer a terse response. 52.02. What is the difference between the Exports(as % of merchandise exports) of Europe(developing only) in 2007 and the Exports(as % of merchandise exports) of New Caledonia in 2008?
Provide a short and direct response. 12.04. What is the difference between the Exports(as % of merchandise exports) in Europe(developing only) in 2007 and the Exports(as % of merchandise exports) in Sweden in 2008?
Your answer should be very brief. -11.21. What is the difference between the Exports(as % of merchandise exports) in Europe(developing only) in 2007 and the Exports(as % of merchandise exports) in Uruguay in 2008?
Make the answer very short. 34.92. What is the difference between the Exports(as % of merchandise exports) in New Caledonia in 2007 and the Exports(as % of merchandise exports) in Sweden in 2008?
Your response must be concise. -15.5. What is the difference between the Exports(as % of merchandise exports) in New Caledonia in 2007 and the Exports(as % of merchandise exports) in Uruguay in 2008?
Your answer should be very brief. 30.63. What is the difference between the Exports(as % of merchandise exports) in Sweden in 2007 and the Exports(as % of merchandise exports) in Uruguay in 2008?
Offer a terse response. 48.48. What is the difference between the Exports(as % of merchandise exports) of Europe(developing only) in 2007 and the Exports(as % of merchandise exports) of New Caledonia in 2009?
Keep it short and to the point. -15.3. What is the difference between the Exports(as % of merchandise exports) in Europe(developing only) in 2007 and the Exports(as % of merchandise exports) in Sweden in 2009?
Keep it short and to the point. -11.99. What is the difference between the Exports(as % of merchandise exports) in Europe(developing only) in 2007 and the Exports(as % of merchandise exports) in Uruguay in 2009?
Provide a succinct answer. 38.35. What is the difference between the Exports(as % of merchandise exports) in New Caledonia in 2007 and the Exports(as % of merchandise exports) in Sweden in 2009?
Ensure brevity in your answer.  -16.28. What is the difference between the Exports(as % of merchandise exports) in New Caledonia in 2007 and the Exports(as % of merchandise exports) in Uruguay in 2009?
Your answer should be very brief. 34.06. What is the difference between the Exports(as % of merchandise exports) in Sweden in 2007 and the Exports(as % of merchandise exports) in Uruguay in 2009?
Give a very brief answer. 51.92. What is the difference between the Exports(as % of merchandise exports) of Europe(developing only) in 2008 and the Exports(as % of merchandise exports) of New Caledonia in 2009?
Offer a terse response. -17.47. What is the difference between the Exports(as % of merchandise exports) of Europe(developing only) in 2008 and the Exports(as % of merchandise exports) of Sweden in 2009?
Make the answer very short. -14.16. What is the difference between the Exports(as % of merchandise exports) of Europe(developing only) in 2008 and the Exports(as % of merchandise exports) of Uruguay in 2009?
Ensure brevity in your answer.  36.19. What is the difference between the Exports(as % of merchandise exports) in New Caledonia in 2008 and the Exports(as % of merchandise exports) in Sweden in 2009?
Make the answer very short. -24.03. What is the difference between the Exports(as % of merchandise exports) of New Caledonia in 2008 and the Exports(as % of merchandise exports) of Uruguay in 2009?
Your answer should be very brief. 26.31. What is the difference between the Exports(as % of merchandise exports) of Sweden in 2008 and the Exports(as % of merchandise exports) of Uruguay in 2009?
Your answer should be compact. 49.56. What is the average Exports(as % of merchandise exports) of Europe(developing only) per year?
Offer a very short reply. 63.36. What is the average Exports(as % of merchandise exports) in New Caledonia per year?
Provide a succinct answer. 65.54. What is the average Exports(as % of merchandise exports) of Sweden per year?
Offer a terse response. 78.58. What is the average Exports(as % of merchandise exports) of Uruguay per year?
Your answer should be compact. 31.54. In the year 2002, what is the difference between the Exports(as % of merchandise exports) in Europe(developing only) and Exports(as % of merchandise exports) in New Caledonia?
Offer a terse response. -4.97. In the year 2002, what is the difference between the Exports(as % of merchandise exports) of Europe(developing only) and Exports(as % of merchandise exports) of Sweden?
Make the answer very short. -16.91. In the year 2002, what is the difference between the Exports(as % of merchandise exports) of Europe(developing only) and Exports(as % of merchandise exports) of Uruguay?
Your answer should be compact. 28.29. In the year 2002, what is the difference between the Exports(as % of merchandise exports) of New Caledonia and Exports(as % of merchandise exports) of Sweden?
Offer a very short reply. -11.94. In the year 2002, what is the difference between the Exports(as % of merchandise exports) in New Caledonia and Exports(as % of merchandise exports) in Uruguay?
Provide a short and direct response. 33.26. In the year 2002, what is the difference between the Exports(as % of merchandise exports) of Sweden and Exports(as % of merchandise exports) of Uruguay?
Your answer should be very brief. 45.2. In the year 2003, what is the difference between the Exports(as % of merchandise exports) of Europe(developing only) and Exports(as % of merchandise exports) of New Caledonia?
Provide a succinct answer. -4.07. In the year 2003, what is the difference between the Exports(as % of merchandise exports) of Europe(developing only) and Exports(as % of merchandise exports) of Sweden?
Give a very brief answer. -15.99. In the year 2003, what is the difference between the Exports(as % of merchandise exports) of Europe(developing only) and Exports(as % of merchandise exports) of Uruguay?
Your answer should be compact. 31.13. In the year 2003, what is the difference between the Exports(as % of merchandise exports) of New Caledonia and Exports(as % of merchandise exports) of Sweden?
Offer a very short reply. -11.93. In the year 2003, what is the difference between the Exports(as % of merchandise exports) in New Caledonia and Exports(as % of merchandise exports) in Uruguay?
Provide a short and direct response. 35.19. In the year 2003, what is the difference between the Exports(as % of merchandise exports) of Sweden and Exports(as % of merchandise exports) of Uruguay?
Your answer should be compact. 47.12. In the year 2004, what is the difference between the Exports(as % of merchandise exports) of Europe(developing only) and Exports(as % of merchandise exports) of New Caledonia?
Ensure brevity in your answer.  0.19. In the year 2004, what is the difference between the Exports(as % of merchandise exports) in Europe(developing only) and Exports(as % of merchandise exports) in Sweden?
Provide a short and direct response. -15.27. In the year 2004, what is the difference between the Exports(as % of merchandise exports) in Europe(developing only) and Exports(as % of merchandise exports) in Uruguay?
Ensure brevity in your answer.  33.6. In the year 2004, what is the difference between the Exports(as % of merchandise exports) of New Caledonia and Exports(as % of merchandise exports) of Sweden?
Give a very brief answer. -15.46. In the year 2004, what is the difference between the Exports(as % of merchandise exports) in New Caledonia and Exports(as % of merchandise exports) in Uruguay?
Ensure brevity in your answer.  33.41. In the year 2004, what is the difference between the Exports(as % of merchandise exports) in Sweden and Exports(as % of merchandise exports) in Uruguay?
Provide a succinct answer. 48.86. In the year 2005, what is the difference between the Exports(as % of merchandise exports) in Europe(developing only) and Exports(as % of merchandise exports) in New Caledonia?
Ensure brevity in your answer.  -4.8. In the year 2005, what is the difference between the Exports(as % of merchandise exports) in Europe(developing only) and Exports(as % of merchandise exports) in Sweden?
Provide a succinct answer. -15.84. In the year 2005, what is the difference between the Exports(as % of merchandise exports) of Europe(developing only) and Exports(as % of merchandise exports) of Uruguay?
Keep it short and to the point. 31.03. In the year 2005, what is the difference between the Exports(as % of merchandise exports) of New Caledonia and Exports(as % of merchandise exports) of Sweden?
Ensure brevity in your answer.  -11.04. In the year 2005, what is the difference between the Exports(as % of merchandise exports) of New Caledonia and Exports(as % of merchandise exports) of Uruguay?
Your answer should be compact. 35.84. In the year 2005, what is the difference between the Exports(as % of merchandise exports) in Sweden and Exports(as % of merchandise exports) in Uruguay?
Offer a terse response. 46.87. In the year 2006, what is the difference between the Exports(as % of merchandise exports) of Europe(developing only) and Exports(as % of merchandise exports) of New Caledonia?
Keep it short and to the point. 1.23. In the year 2006, what is the difference between the Exports(as % of merchandise exports) of Europe(developing only) and Exports(as % of merchandise exports) of Sweden?
Your response must be concise. -14.91. In the year 2006, what is the difference between the Exports(as % of merchandise exports) in Europe(developing only) and Exports(as % of merchandise exports) in Uruguay?
Keep it short and to the point. 30.97. In the year 2006, what is the difference between the Exports(as % of merchandise exports) in New Caledonia and Exports(as % of merchandise exports) in Sweden?
Make the answer very short. -16.14. In the year 2006, what is the difference between the Exports(as % of merchandise exports) in New Caledonia and Exports(as % of merchandise exports) in Uruguay?
Keep it short and to the point. 29.74. In the year 2006, what is the difference between the Exports(as % of merchandise exports) of Sweden and Exports(as % of merchandise exports) of Uruguay?
Keep it short and to the point. 45.88. In the year 2007, what is the difference between the Exports(as % of merchandise exports) of Europe(developing only) and Exports(as % of merchandise exports) of New Caledonia?
Make the answer very short. 4.29. In the year 2007, what is the difference between the Exports(as % of merchandise exports) of Europe(developing only) and Exports(as % of merchandise exports) of Sweden?
Your answer should be very brief. -13.56. In the year 2007, what is the difference between the Exports(as % of merchandise exports) of Europe(developing only) and Exports(as % of merchandise exports) of Uruguay?
Your response must be concise. 32.31. In the year 2007, what is the difference between the Exports(as % of merchandise exports) of New Caledonia and Exports(as % of merchandise exports) of Sweden?
Give a very brief answer. -17.85. In the year 2007, what is the difference between the Exports(as % of merchandise exports) in New Caledonia and Exports(as % of merchandise exports) in Uruguay?
Offer a terse response. 28.02. In the year 2007, what is the difference between the Exports(as % of merchandise exports) in Sweden and Exports(as % of merchandise exports) in Uruguay?
Offer a terse response. 45.87. In the year 2008, what is the difference between the Exports(as % of merchandise exports) in Europe(developing only) and Exports(as % of merchandise exports) in New Caledonia?
Offer a very short reply. 9.88. In the year 2008, what is the difference between the Exports(as % of merchandise exports) in Europe(developing only) and Exports(as % of merchandise exports) in Sweden?
Offer a very short reply. -13.37. In the year 2008, what is the difference between the Exports(as % of merchandise exports) of Europe(developing only) and Exports(as % of merchandise exports) of Uruguay?
Offer a very short reply. 32.75. In the year 2008, what is the difference between the Exports(as % of merchandise exports) of New Caledonia and Exports(as % of merchandise exports) of Sweden?
Provide a short and direct response. -23.25. In the year 2008, what is the difference between the Exports(as % of merchandise exports) in New Caledonia and Exports(as % of merchandise exports) in Uruguay?
Your answer should be compact. 22.88. In the year 2008, what is the difference between the Exports(as % of merchandise exports) of Sweden and Exports(as % of merchandise exports) of Uruguay?
Provide a succinct answer. 46.13. In the year 2009, what is the difference between the Exports(as % of merchandise exports) of Europe(developing only) and Exports(as % of merchandise exports) of New Caledonia?
Ensure brevity in your answer.  -19.17. In the year 2009, what is the difference between the Exports(as % of merchandise exports) in Europe(developing only) and Exports(as % of merchandise exports) in Sweden?
Your response must be concise. -15.86. In the year 2009, what is the difference between the Exports(as % of merchandise exports) of Europe(developing only) and Exports(as % of merchandise exports) of Uruguay?
Your answer should be very brief. 34.48. In the year 2009, what is the difference between the Exports(as % of merchandise exports) in New Caledonia and Exports(as % of merchandise exports) in Sweden?
Your answer should be very brief. 3.31. In the year 2009, what is the difference between the Exports(as % of merchandise exports) in New Caledonia and Exports(as % of merchandise exports) in Uruguay?
Offer a very short reply. 53.65. In the year 2009, what is the difference between the Exports(as % of merchandise exports) in Sweden and Exports(as % of merchandise exports) in Uruguay?
Provide a succinct answer. 50.34. What is the ratio of the Exports(as % of merchandise exports) of New Caledonia in 2002 to that in 2003?
Your response must be concise. 1.01. What is the ratio of the Exports(as % of merchandise exports) of Sweden in 2002 to that in 2003?
Provide a succinct answer. 1.01. What is the ratio of the Exports(as % of merchandise exports) in Uruguay in 2002 to that in 2003?
Make the answer very short. 1.08. What is the ratio of the Exports(as % of merchandise exports) in New Caledonia in 2002 to that in 2004?
Your answer should be compact. 1.07. What is the ratio of the Exports(as % of merchandise exports) of Sweden in 2002 to that in 2004?
Your answer should be compact. 1.01. What is the ratio of the Exports(as % of merchandise exports) in Uruguay in 2002 to that in 2004?
Your response must be concise. 1.15. What is the ratio of the Exports(as % of merchandise exports) of Europe(developing only) in 2002 to that in 2005?
Your response must be concise. 1.03. What is the ratio of the Exports(as % of merchandise exports) in New Caledonia in 2002 to that in 2005?
Offer a very short reply. 1.03. What is the ratio of the Exports(as % of merchandise exports) of Sweden in 2002 to that in 2005?
Offer a very short reply. 1.04. What is the ratio of the Exports(as % of merchandise exports) of Uruguay in 2002 to that in 2005?
Keep it short and to the point. 1.15. What is the ratio of the Exports(as % of merchandise exports) in Europe(developing only) in 2002 to that in 2006?
Offer a terse response. 1.04. What is the ratio of the Exports(as % of merchandise exports) in New Caledonia in 2002 to that in 2006?
Offer a very short reply. 1.14. What is the ratio of the Exports(as % of merchandise exports) in Sweden in 2002 to that in 2006?
Provide a succinct answer. 1.06. What is the ratio of the Exports(as % of merchandise exports) of Uruguay in 2002 to that in 2006?
Keep it short and to the point. 1.16. What is the ratio of the Exports(as % of merchandise exports) in Europe(developing only) in 2002 to that in 2007?
Your answer should be compact. 1.02. What is the ratio of the Exports(as % of merchandise exports) in New Caledonia in 2002 to that in 2007?
Provide a short and direct response. 1.17. What is the ratio of the Exports(as % of merchandise exports) in Sweden in 2002 to that in 2007?
Offer a very short reply. 1.06. What is the ratio of the Exports(as % of merchandise exports) of Uruguay in 2002 to that in 2007?
Your answer should be very brief. 1.16. What is the ratio of the Exports(as % of merchandise exports) in Europe(developing only) in 2002 to that in 2008?
Offer a very short reply. 1.05. What is the ratio of the Exports(as % of merchandise exports) of New Caledonia in 2002 to that in 2008?
Ensure brevity in your answer.  1.35. What is the ratio of the Exports(as % of merchandise exports) in Sweden in 2002 to that in 2008?
Make the answer very short. 1.09. What is the ratio of the Exports(as % of merchandise exports) of Uruguay in 2002 to that in 2008?
Provide a short and direct response. 1.27. What is the ratio of the Exports(as % of merchandise exports) in Europe(developing only) in 2002 to that in 2009?
Offer a very short reply. 1.08. What is the ratio of the Exports(as % of merchandise exports) of New Caledonia in 2002 to that in 2009?
Your response must be concise. 0.88. What is the ratio of the Exports(as % of merchandise exports) of Sweden in 2002 to that in 2009?
Give a very brief answer. 1.08. What is the ratio of the Exports(as % of merchandise exports) of Uruguay in 2002 to that in 2009?
Offer a very short reply. 1.44. What is the ratio of the Exports(as % of merchandise exports) of New Caledonia in 2003 to that in 2004?
Your response must be concise. 1.06. What is the ratio of the Exports(as % of merchandise exports) in Uruguay in 2003 to that in 2004?
Make the answer very short. 1.07. What is the ratio of the Exports(as % of merchandise exports) of Europe(developing only) in 2003 to that in 2005?
Give a very brief answer. 1.04. What is the ratio of the Exports(as % of merchandise exports) in New Caledonia in 2003 to that in 2005?
Keep it short and to the point. 1.02. What is the ratio of the Exports(as % of merchandise exports) of Sweden in 2003 to that in 2005?
Provide a succinct answer. 1.03. What is the ratio of the Exports(as % of merchandise exports) of Uruguay in 2003 to that in 2005?
Make the answer very short. 1.07. What is the ratio of the Exports(as % of merchandise exports) in Europe(developing only) in 2003 to that in 2006?
Provide a short and direct response. 1.04. What is the ratio of the Exports(as % of merchandise exports) in New Caledonia in 2003 to that in 2006?
Provide a short and direct response. 1.13. What is the ratio of the Exports(as % of merchandise exports) in Sweden in 2003 to that in 2006?
Your answer should be compact. 1.05. What is the ratio of the Exports(as % of merchandise exports) of Uruguay in 2003 to that in 2006?
Your answer should be compact. 1.08. What is the ratio of the Exports(as % of merchandise exports) of Europe(developing only) in 2003 to that in 2007?
Provide a short and direct response. 1.02. What is the ratio of the Exports(as % of merchandise exports) of New Caledonia in 2003 to that in 2007?
Keep it short and to the point. 1.16. What is the ratio of the Exports(as % of merchandise exports) in Sweden in 2003 to that in 2007?
Offer a terse response. 1.05. What is the ratio of the Exports(as % of merchandise exports) in Uruguay in 2003 to that in 2007?
Offer a terse response. 1.08. What is the ratio of the Exports(as % of merchandise exports) of Europe(developing only) in 2003 to that in 2008?
Keep it short and to the point. 1.06. What is the ratio of the Exports(as % of merchandise exports) in New Caledonia in 2003 to that in 2008?
Offer a terse response. 1.34. What is the ratio of the Exports(as % of merchandise exports) of Sweden in 2003 to that in 2008?
Offer a terse response. 1.08. What is the ratio of the Exports(as % of merchandise exports) in Uruguay in 2003 to that in 2008?
Provide a succinct answer. 1.18. What is the ratio of the Exports(as % of merchandise exports) in Europe(developing only) in 2003 to that in 2009?
Provide a succinct answer. 1.09. What is the ratio of the Exports(as % of merchandise exports) of New Caledonia in 2003 to that in 2009?
Your answer should be compact. 0.87. What is the ratio of the Exports(as % of merchandise exports) in Sweden in 2003 to that in 2009?
Provide a short and direct response. 1.07. What is the ratio of the Exports(as % of merchandise exports) in Uruguay in 2003 to that in 2009?
Provide a short and direct response. 1.33. What is the ratio of the Exports(as % of merchandise exports) of Europe(developing only) in 2004 to that in 2005?
Provide a short and direct response. 1.04. What is the ratio of the Exports(as % of merchandise exports) in New Caledonia in 2004 to that in 2005?
Ensure brevity in your answer.  0.96. What is the ratio of the Exports(as % of merchandise exports) in Sweden in 2004 to that in 2005?
Give a very brief answer. 1.02. What is the ratio of the Exports(as % of merchandise exports) of Europe(developing only) in 2004 to that in 2006?
Your response must be concise. 1.04. What is the ratio of the Exports(as % of merchandise exports) of New Caledonia in 2004 to that in 2006?
Ensure brevity in your answer.  1.06. What is the ratio of the Exports(as % of merchandise exports) of Sweden in 2004 to that in 2006?
Your answer should be compact. 1.04. What is the ratio of the Exports(as % of merchandise exports) in Uruguay in 2004 to that in 2006?
Provide a short and direct response. 1.01. What is the ratio of the Exports(as % of merchandise exports) in Europe(developing only) in 2004 to that in 2007?
Your answer should be very brief. 1.02. What is the ratio of the Exports(as % of merchandise exports) in New Caledonia in 2004 to that in 2007?
Your answer should be compact. 1.09. What is the ratio of the Exports(as % of merchandise exports) of Sweden in 2004 to that in 2007?
Ensure brevity in your answer.  1.04. What is the ratio of the Exports(as % of merchandise exports) in Uruguay in 2004 to that in 2007?
Provide a short and direct response. 1.01. What is the ratio of the Exports(as % of merchandise exports) of Europe(developing only) in 2004 to that in 2008?
Offer a terse response. 1.06. What is the ratio of the Exports(as % of merchandise exports) in New Caledonia in 2004 to that in 2008?
Offer a terse response. 1.26. What is the ratio of the Exports(as % of merchandise exports) in Sweden in 2004 to that in 2008?
Your answer should be compact. 1.07. What is the ratio of the Exports(as % of merchandise exports) in Uruguay in 2004 to that in 2008?
Keep it short and to the point. 1.1. What is the ratio of the Exports(as % of merchandise exports) of Europe(developing only) in 2004 to that in 2009?
Provide a succinct answer. 1.09. What is the ratio of the Exports(as % of merchandise exports) of New Caledonia in 2004 to that in 2009?
Provide a succinct answer. 0.82. What is the ratio of the Exports(as % of merchandise exports) in Sweden in 2004 to that in 2009?
Provide a succinct answer. 1.06. What is the ratio of the Exports(as % of merchandise exports) in Uruguay in 2004 to that in 2009?
Your answer should be compact. 1.25. What is the ratio of the Exports(as % of merchandise exports) in Europe(developing only) in 2005 to that in 2006?
Provide a short and direct response. 1. What is the ratio of the Exports(as % of merchandise exports) in New Caledonia in 2005 to that in 2006?
Your answer should be compact. 1.1. What is the ratio of the Exports(as % of merchandise exports) of Sweden in 2005 to that in 2006?
Provide a succinct answer. 1.02. What is the ratio of the Exports(as % of merchandise exports) of Europe(developing only) in 2005 to that in 2007?
Offer a terse response. 0.98. What is the ratio of the Exports(as % of merchandise exports) of New Caledonia in 2005 to that in 2007?
Your answer should be very brief. 1.14. What is the ratio of the Exports(as % of merchandise exports) of Sweden in 2005 to that in 2007?
Your answer should be compact. 1.02. What is the ratio of the Exports(as % of merchandise exports) of Uruguay in 2005 to that in 2007?
Provide a succinct answer. 1.01. What is the ratio of the Exports(as % of merchandise exports) in New Caledonia in 2005 to that in 2008?
Provide a succinct answer. 1.31. What is the ratio of the Exports(as % of merchandise exports) of Sweden in 2005 to that in 2008?
Your response must be concise. 1.05. What is the ratio of the Exports(as % of merchandise exports) of Uruguay in 2005 to that in 2008?
Your answer should be compact. 1.1. What is the ratio of the Exports(as % of merchandise exports) in Europe(developing only) in 2005 to that in 2009?
Provide a succinct answer. 1.05. What is the ratio of the Exports(as % of merchandise exports) in New Caledonia in 2005 to that in 2009?
Provide a succinct answer. 0.85. What is the ratio of the Exports(as % of merchandise exports) in Sweden in 2005 to that in 2009?
Ensure brevity in your answer.  1.04. What is the ratio of the Exports(as % of merchandise exports) of Uruguay in 2005 to that in 2009?
Provide a short and direct response. 1.25. What is the ratio of the Exports(as % of merchandise exports) of Europe(developing only) in 2006 to that in 2007?
Provide a short and direct response. 0.98. What is the ratio of the Exports(as % of merchandise exports) of New Caledonia in 2006 to that in 2007?
Keep it short and to the point. 1.03. What is the ratio of the Exports(as % of merchandise exports) of Sweden in 2006 to that in 2007?
Give a very brief answer. 1. What is the ratio of the Exports(as % of merchandise exports) of Uruguay in 2006 to that in 2007?
Provide a succinct answer. 1. What is the ratio of the Exports(as % of merchandise exports) in Europe(developing only) in 2006 to that in 2008?
Your answer should be very brief. 1.01. What is the ratio of the Exports(as % of merchandise exports) of New Caledonia in 2006 to that in 2008?
Your answer should be compact. 1.18. What is the ratio of the Exports(as % of merchandise exports) of Sweden in 2006 to that in 2008?
Provide a short and direct response. 1.03. What is the ratio of the Exports(as % of merchandise exports) in Uruguay in 2006 to that in 2008?
Provide a short and direct response. 1.09. What is the ratio of the Exports(as % of merchandise exports) of Europe(developing only) in 2006 to that in 2009?
Make the answer very short. 1.04. What is the ratio of the Exports(as % of merchandise exports) in New Caledonia in 2006 to that in 2009?
Your response must be concise. 0.78. What is the ratio of the Exports(as % of merchandise exports) of Sweden in 2006 to that in 2009?
Make the answer very short. 1.02. What is the ratio of the Exports(as % of merchandise exports) in Uruguay in 2006 to that in 2009?
Your answer should be compact. 1.24. What is the ratio of the Exports(as % of merchandise exports) of Europe(developing only) in 2007 to that in 2008?
Give a very brief answer. 1.04. What is the ratio of the Exports(as % of merchandise exports) in New Caledonia in 2007 to that in 2008?
Provide a short and direct response. 1.15. What is the ratio of the Exports(as % of merchandise exports) of Sweden in 2007 to that in 2008?
Give a very brief answer. 1.03. What is the ratio of the Exports(as % of merchandise exports) in Uruguay in 2007 to that in 2008?
Make the answer very short. 1.09. What is the ratio of the Exports(as % of merchandise exports) of Europe(developing only) in 2007 to that in 2009?
Give a very brief answer. 1.06. What is the ratio of the Exports(as % of merchandise exports) in New Caledonia in 2007 to that in 2009?
Provide a short and direct response. 0.75. What is the ratio of the Exports(as % of merchandise exports) of Sweden in 2007 to that in 2009?
Give a very brief answer. 1.02. What is the ratio of the Exports(as % of merchandise exports) of Uruguay in 2007 to that in 2009?
Your answer should be very brief. 1.24. What is the ratio of the Exports(as % of merchandise exports) of Europe(developing only) in 2008 to that in 2009?
Offer a very short reply. 1.03. What is the ratio of the Exports(as % of merchandise exports) of New Caledonia in 2008 to that in 2009?
Offer a terse response. 0.65. What is the ratio of the Exports(as % of merchandise exports) of Uruguay in 2008 to that in 2009?
Provide a succinct answer. 1.13. What is the difference between the highest and the second highest Exports(as % of merchandise exports) of Europe(developing only)?
Provide a succinct answer. 0.26. What is the difference between the highest and the second highest Exports(as % of merchandise exports) in New Caledonia?
Your answer should be very brief. 9.22. What is the difference between the highest and the second highest Exports(as % of merchandise exports) in Sweden?
Ensure brevity in your answer.  0.74. What is the difference between the highest and the second highest Exports(as % of merchandise exports) of Uruguay?
Your answer should be very brief. 2.66. What is the difference between the highest and the lowest Exports(as % of merchandise exports) in Europe(developing only)?
Ensure brevity in your answer.  5.42. What is the difference between the highest and the lowest Exports(as % of merchandise exports) in New Caledonia?
Offer a terse response. 27.34. What is the difference between the highest and the lowest Exports(as % of merchandise exports) in Sweden?
Provide a short and direct response. 6.81. What is the difference between the highest and the lowest Exports(as % of merchandise exports) in Uruguay?
Provide a succinct answer. 11.17. 